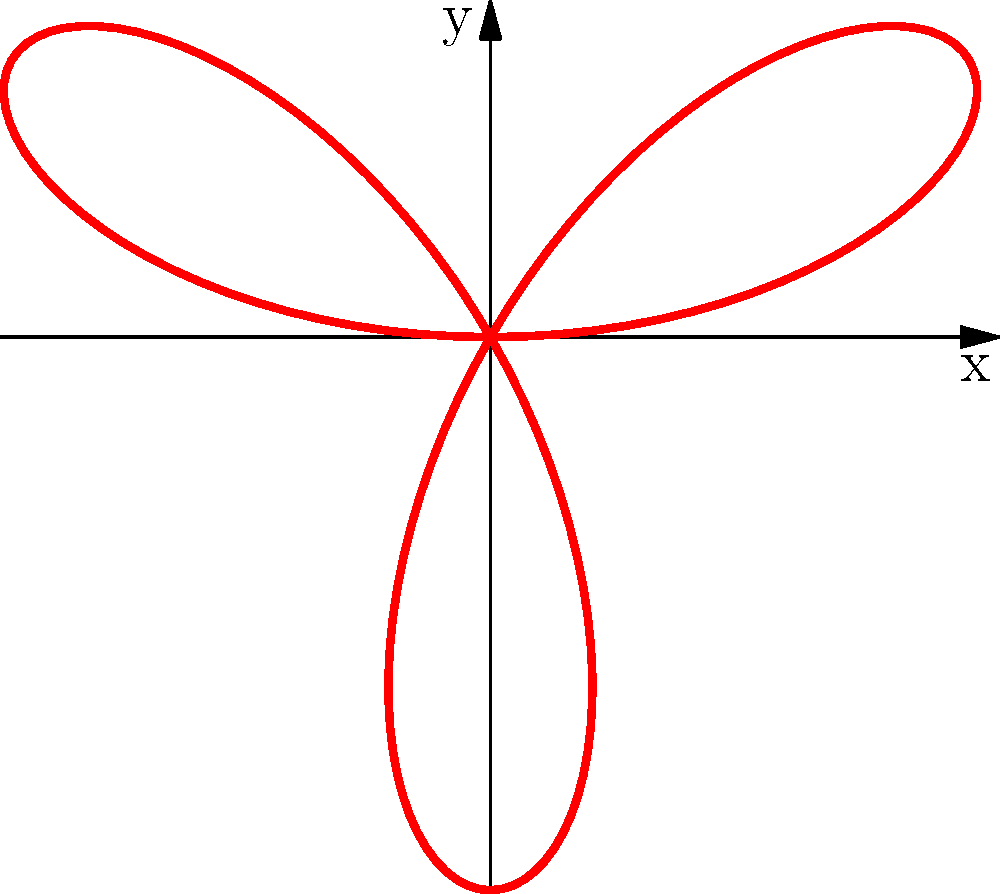In Azerbaijani theatrical costume design, a particular ornamental pattern can be represented by the polar rose equation $r = 2\sin(3\theta)$. How many petals does this polar rose have, and what does this number symbolize in traditional Azerbaijani theatre costumes? To determine the number of petals in this polar rose:

1. The general form of a polar rose is $r = a \sin(n\theta)$ or $r = a \cos(n\theta)$, where $n$ determines the number of petals.

2. In our equation $r = 2\sin(3\theta)$, we have $n = 3$.

3. For odd values of $n$, the number of petals is equal to $n$.

4. Since $n = 3$, this polar rose has 3 petals.

In traditional Azerbaijani theatre costumes, the number 3 often symbolizes:

5. The three stages of life: birth, life, and death.

6. The three elements: earth, water, and fire.

7. The concept of completeness and balance in nature and art.

This three-petaled design might be used in costumes to represent these fundamental concepts in Azerbaijani culture and storytelling.
Answer: 3 petals; symbolizes life stages, elements, or completeness in Azerbaijani theatre 